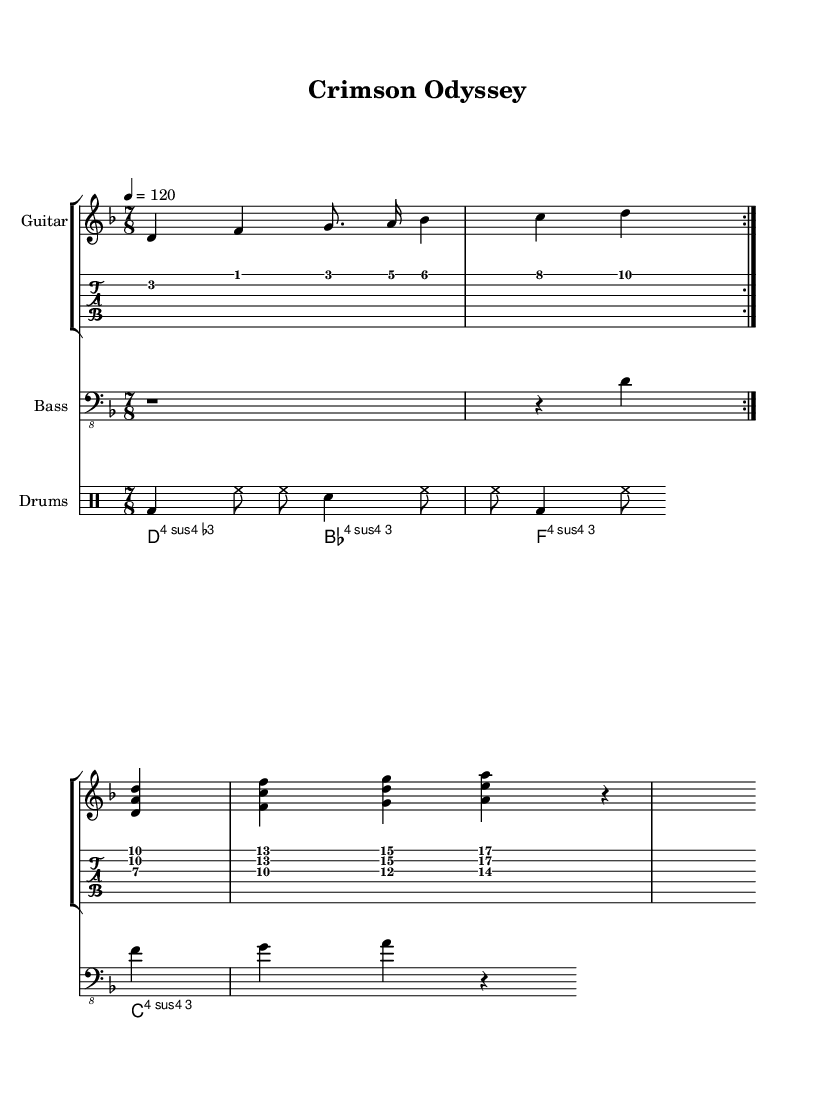What is the key signature of this music? The key signature is two flats, which corresponds to the key of D minor. This can be identified from the initial part of the staff that indicates the flats present in the key signature.
Answer: D minor What is the time signature of this piece? The time signature shows that there are seven beats per measure, as indicated on the staff at the beginning of the piece. This means the rhythmic structure is based on groupings of seven.
Answer: 7/8 What is the tempo marking for this track? The tempo marking is shown as "4 = 120," indicating that there are 120 beats per minute with a quarter note as the beat. This guides the performance speed of the piece.
Answer: 120 How many repetitions of the guitar riff are indicated? The music score has a marking that shows the guitar riff should be repeated twice before moving to the next section. This is noted by the "repeat volta" instruction.
Answer: 2 What is the main chord progression in the chorus? The main chord progression in the chorus consists of four chords: D minor, B flat major, F major, and C major, arranged sequentially. This reveals the harmonic structure of the chorus section.
Answer: D minor, B flat major, F major, C major What unique rhythmic feature is present in the drum part? The drum part features a combination of alternating bass drum and hi-hat notes, creating a syncopated rhythm that enhances the progressive metal style. This is evident in the detailed drum pattern notation.
Answer: Syncopation What elements in this piece are characteristic of progressive metal? The piece includes complex time signatures, varied tempos, intricate guitar riffs, and dynamic contrasts throughout, which are all hallmarks of progressive metal genre. This can be deduced from the music's structure and instrumentation.
Answer: Complex time signatures, intricate guitar riffs, dynamic contrasts 